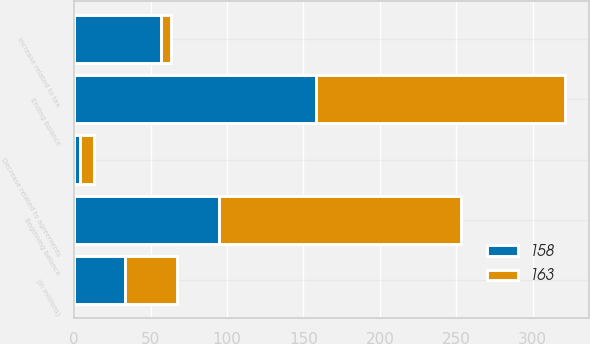Convert chart to OTSL. <chart><loc_0><loc_0><loc_500><loc_500><stacked_bar_chart><ecel><fcel>(In millions)<fcel>Beginning balance<fcel>Decrease related to agreements<fcel>Increase related to tax<fcel>Ending balance<nl><fcel>163<fcel>33.5<fcel>158<fcel>9<fcel>6<fcel>163<nl><fcel>158<fcel>33.5<fcel>95<fcel>4<fcel>57<fcel>158<nl></chart> 